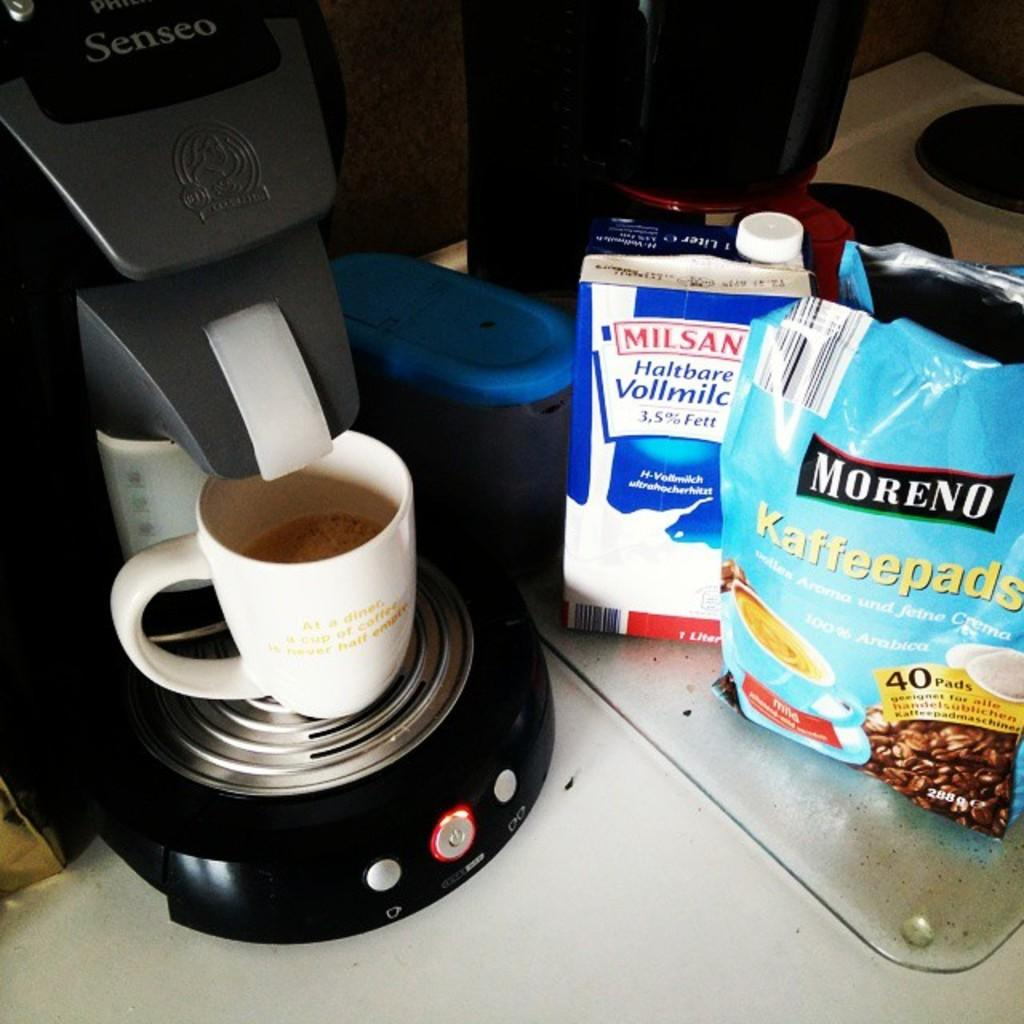How many coffee makers are visible in the image? There are two coffee makers in the image. What else can be seen in the image besides the coffee makers? There is a mug, packets, and a box visible in the image. Where are all the objects located in the image? All objects are on a surface in the image. What type of decision can be seen being made by the jellyfish in the image? There are no jellyfish present in the image, so no decision can be observed. Is there any grass visible in the image? There is no grass present in the image. 